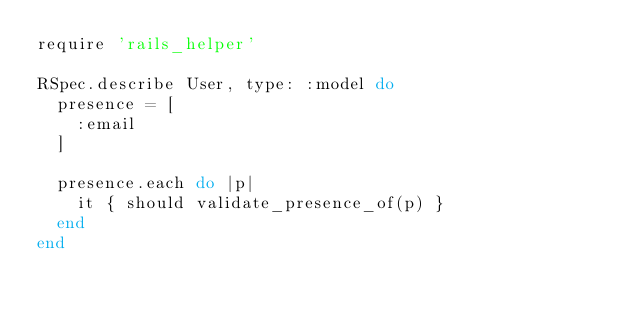<code> <loc_0><loc_0><loc_500><loc_500><_Ruby_>require 'rails_helper'

RSpec.describe User, type: :model do
  presence = [
    :email
  ]

  presence.each do |p|
    it { should validate_presence_of(p) }
  end
end
</code> 